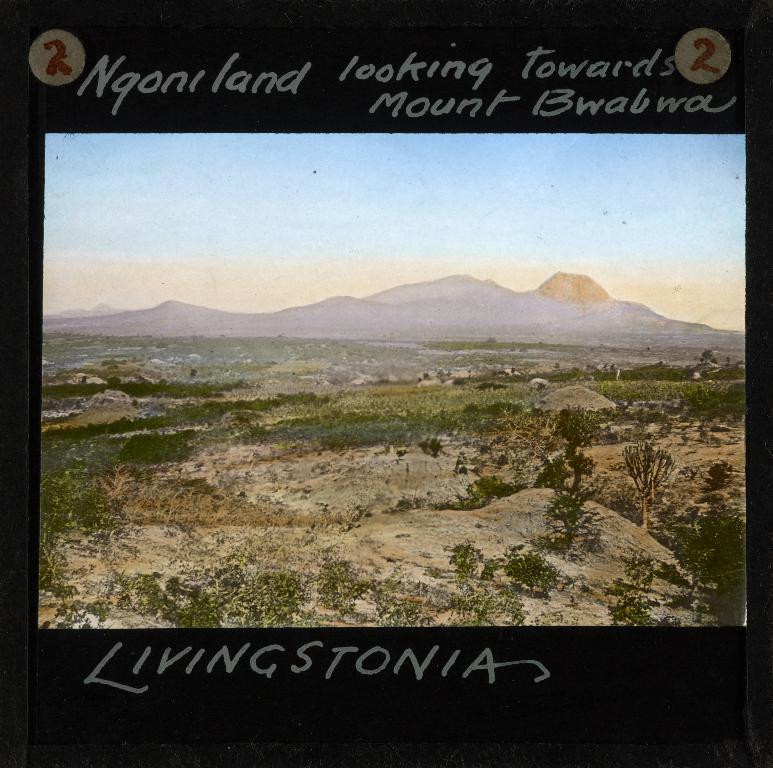Provide a one-sentence caption for the provided image. Sign with land and mountains for Ngoniland mount bwabwa Livingstonia. 